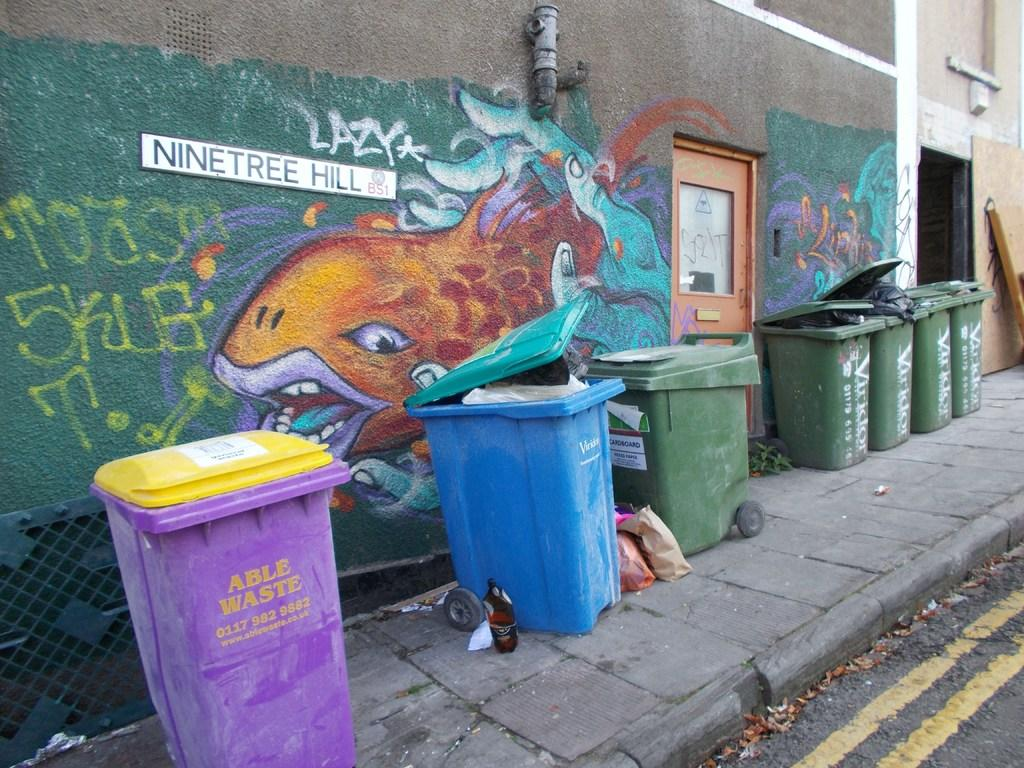Provide a one-sentence caption for the provided image. A picture of an orange fish sits on a wall in front of a blue trash can on Nine Tree Hill Ave. 